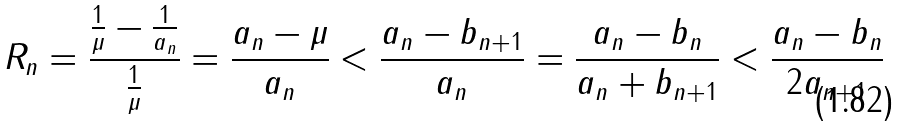<formula> <loc_0><loc_0><loc_500><loc_500>R _ { n } = \frac { \frac { 1 } { \mu } - \frac { 1 } { a _ { n } } } { \frac { 1 } { \mu } } = \frac { a _ { n } - \mu } { a _ { n } } < \frac { a _ { n } - b _ { n + 1 } } { a _ { n } } = \frac { a _ { n } - b _ { n } } { a _ { n } + b _ { n + 1 } } < \frac { a _ { n } - b _ { n } } { 2 a _ { n + 1 } }</formula> 